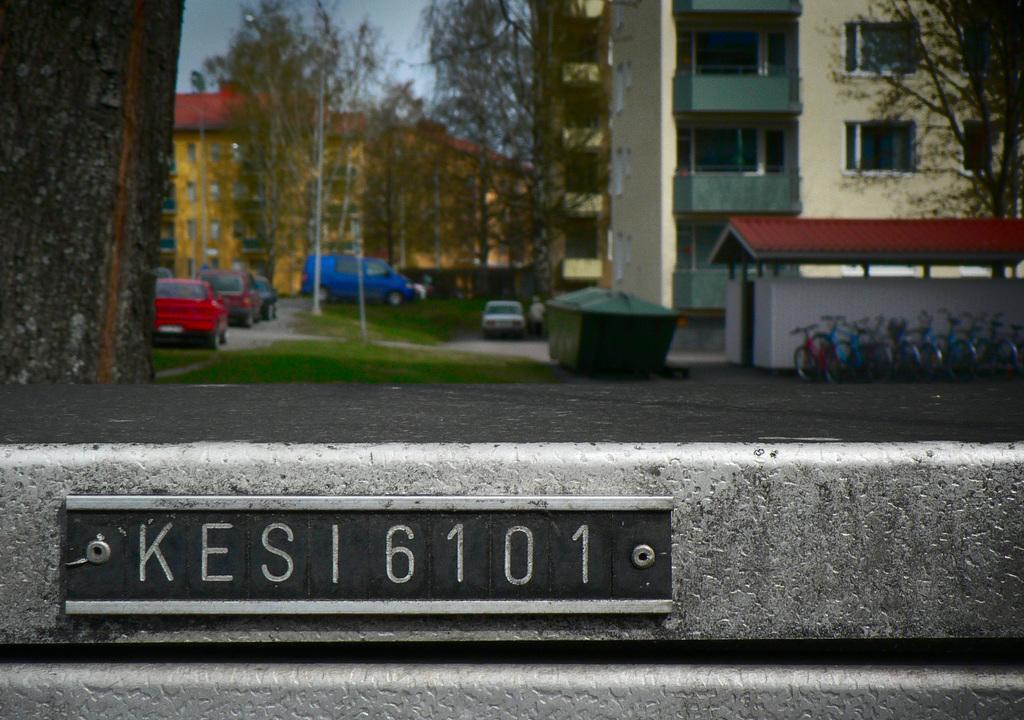Could you give a brief overview of what you see in this image? In the foreground of the image we can see a signboard with some text on it. In the background, we can see a group of cycles placed on the ground, a group of buildings, groups of vehicles parked on the road, trees and sky. 